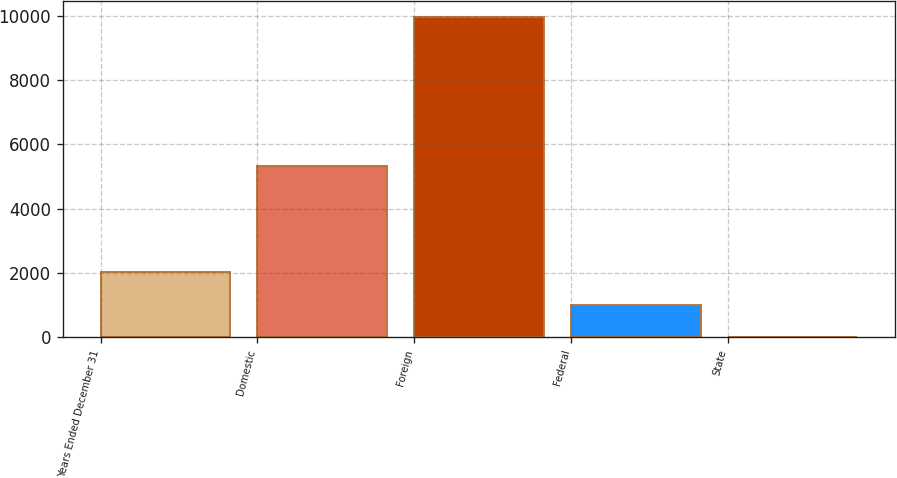<chart> <loc_0><loc_0><loc_500><loc_500><bar_chart><fcel>Years Ended December 31<fcel>Domestic<fcel>Foreign<fcel>Federal<fcel>State<nl><fcel>2009<fcel>5319.5<fcel>9972.3<fcel>1003.71<fcel>7.2<nl></chart> 